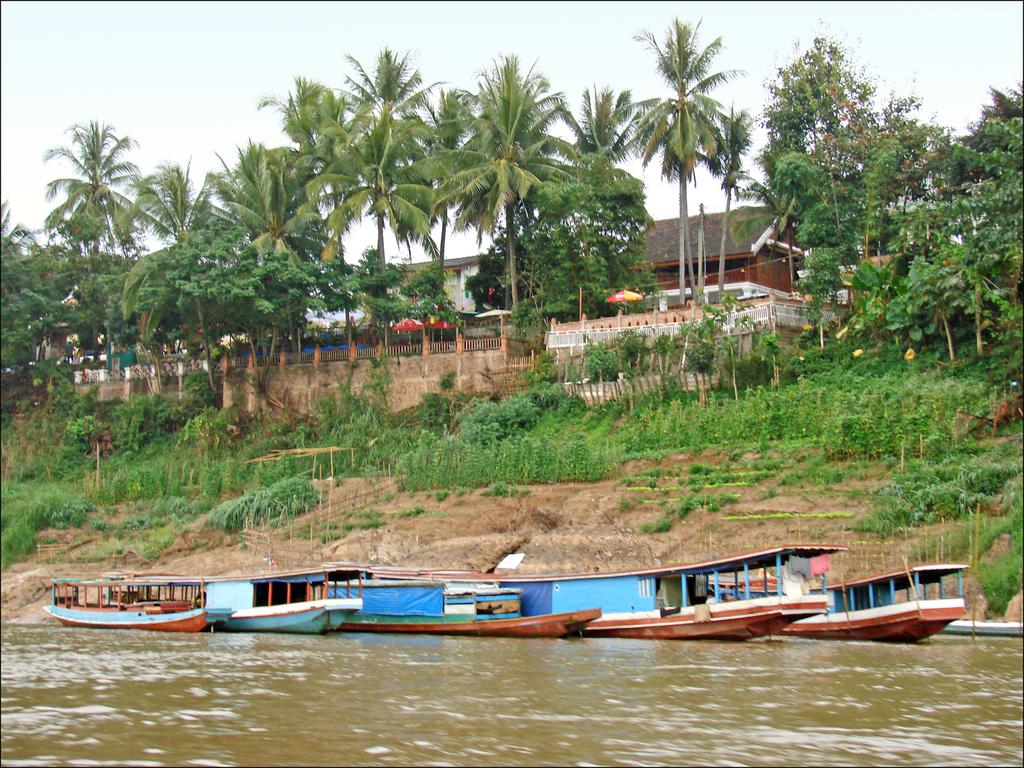What is the main subject in the center of the image? There are boats in the center of the image. What is visible in the front of the image? There is water in the front of the image. What type of natural elements can be seen in the background of the image? There are plants and trees in the background of the image. What is the condition of the sky in the background of the image? The sky is cloudy in the background of the image. What type of man-made structures can be seen in the background of the image? There are buildings in the background of the image. What type of jewel is being used to paddle the boats in the image? There are no jewels present in the image, and the boats are not being paddled with any such objects. 